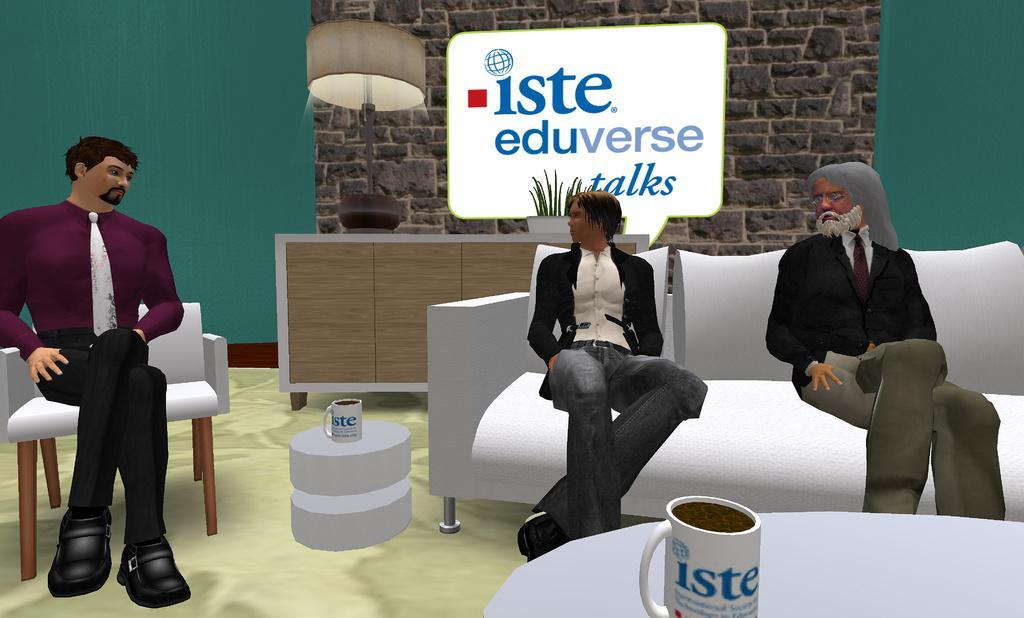Can you describe this image briefly? This image is a animated picture in which I can see three persons are sitting on the sofa in front of a table on which a cup is there. In the background I can see a wall, lamp, board and a houseplant. 